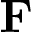<formula> <loc_0><loc_0><loc_500><loc_500>F</formula> 